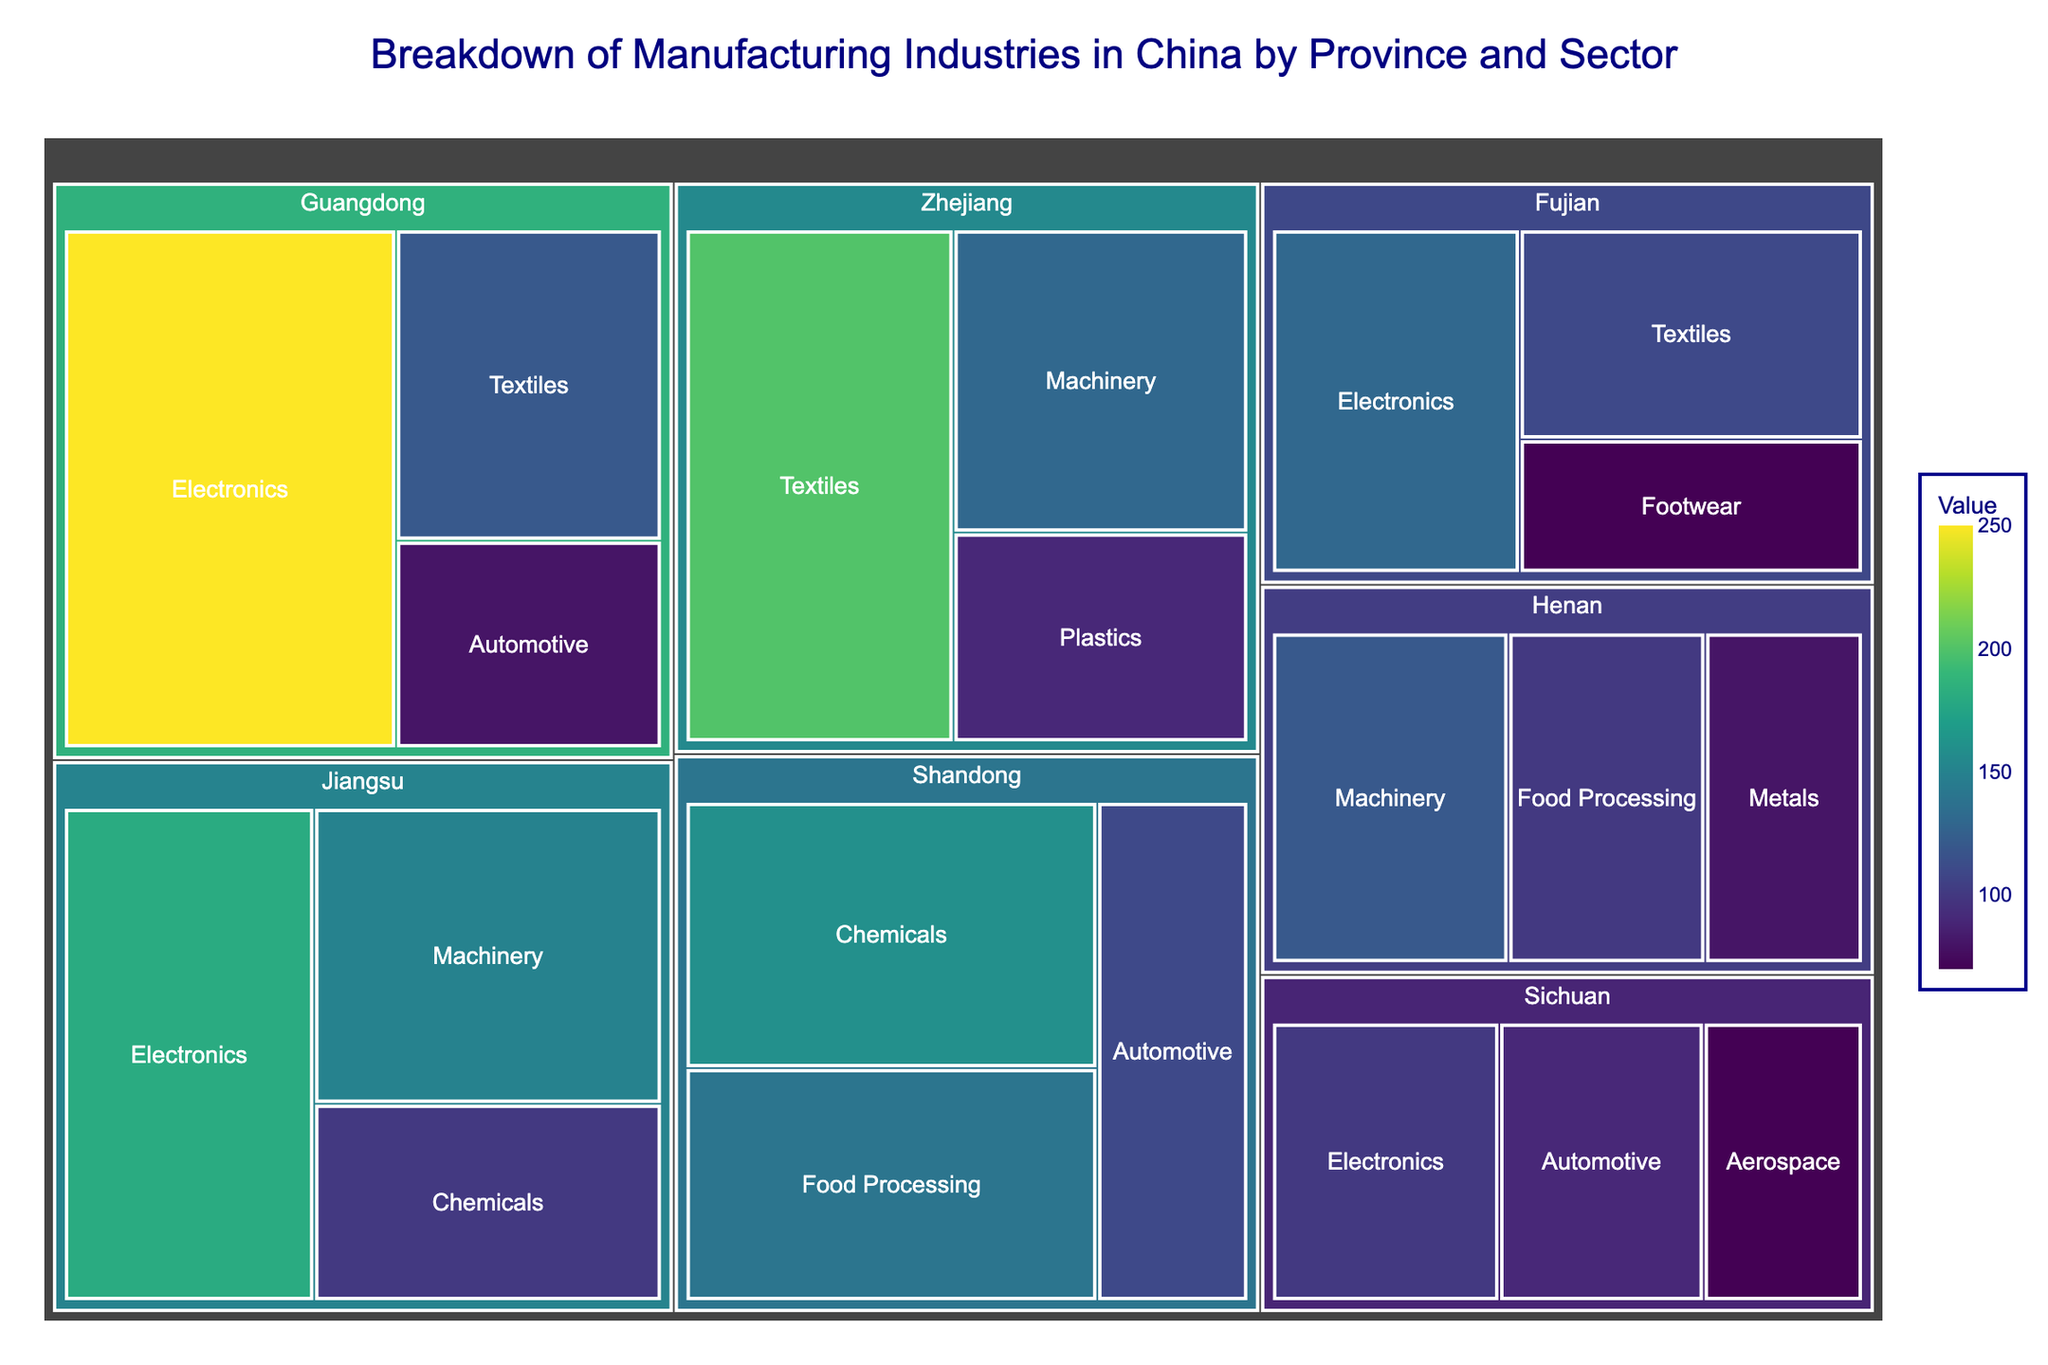What is the title of the figure? The title of the figure is typically displayed at the top and often in a larger or bold font to make it stand out. Here, the title indicates the content and purpose of the visualization.
Answer: Breakdown of Manufacturing Industries in China by Province and Sector Which province has the largest value for Electronics? We need to identify the province with the largest section labeled 'Electronics' within the treemap. Guangdong's Electronics section appears the largest.
Answer: Guangdong How many sectors are represented in Shandong province? Shandong province’s portion of the treemap is divided into sections representing different sectors. Counting these sections gives the number of sectors.
Answer: 3 Which sector has a higher value in Zhejiang, Textiles or Machinery? By comparing the sizes or the numerical values of the Textiles and Machinery sections within Zhejiang, we find Textiles is higher.
Answer: Textiles What is the sum of values for the sectors in Fujian province? Sum the values of all sectors in Fujian: 130 (Electronics) + 110 (Textiles) + 70 (Footwear). 130 + 110 + 70 = 310
Answer: 310 Which has the greatest value in Henan, Food Processing or Metals? Compare the size or numerical values of the 'Food Processing' and 'Metals' sectors within Henan. Food Processing (100) is greater than Metals (80).
Answer: Food Processing What is the total value of the Electronics sector across all provinces? Sum the value of the Electronics sector in each province. Guangdong (250) + Jiangsu (180) + Fujian (130) + Sichuan (100). 250 + 180 + 130 + 100 = 660
Answer: 660 Which province has the most diverse range of manufacturing sectors represented? Look for the province with the most number of different sector sections within the province's portion of the treemap. Several provinces have three different sectors, so they are equally diverse.
Answer: Multiple provinces (e.g., Guangdong, Jiangsu, Shandong, Fujian) What is the difference in value between Automotive in Guangdong and Automotive in Sichuan? Subtract the value for Automotive in Sichuan from the value for Automotive in Guangdong. 80 (Guangdong) - 90 (Sichuan) = -10
Answer: -10 Between Jiangsu and Zhejiang, which one has a larger total value for all its manufacturing sectors combined? Sum the values of all sectors in each province, then compare. Jiangsu: 180 (Electronics) + 150 (Machinery) + 100 (Chemicals) = 430; Zhejiang: 200 (Textiles) + 130 (Machinery) + 90 (Plastics) = 420. Jiangsu is larger.
Answer: Jiangsu 